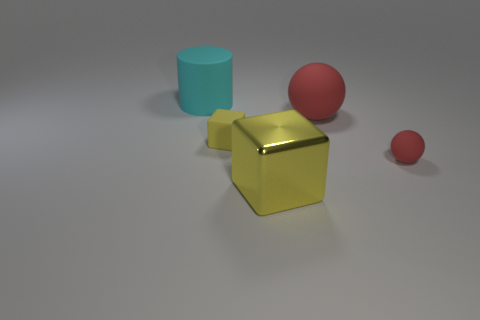What emotions might the colors and composition evoke in a viewer? The subdued palette and the sparse arrangement in the image might evoke a sense of calm and minimalism. The red adds a touch of warmth and energy, balanced by the coolness of the blue, while the striking yellow introduces contrast and visual interest, possibly evoking curiosity or contemplation. 